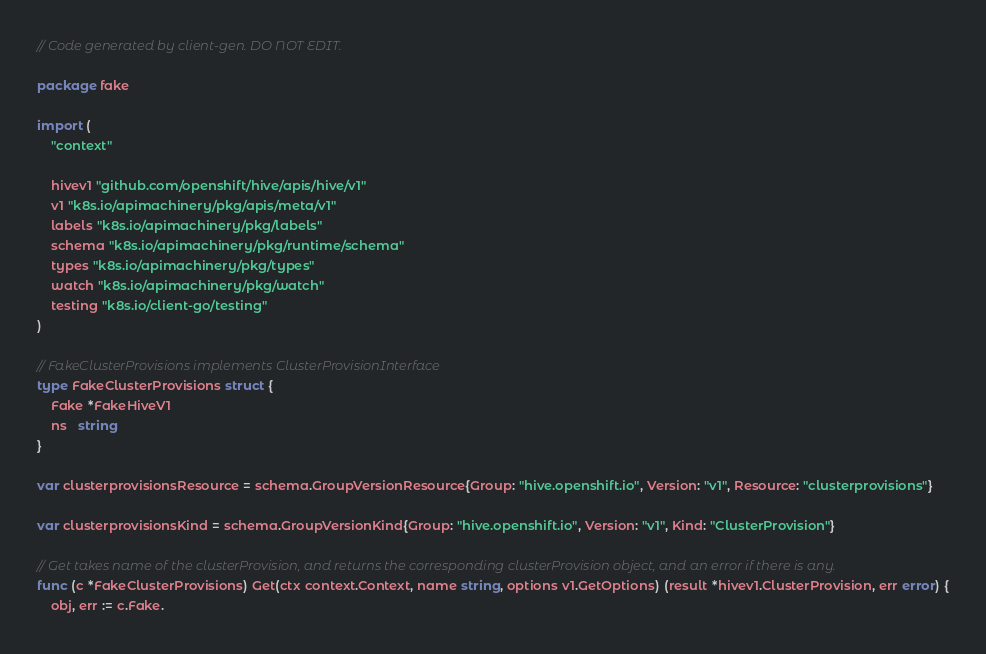<code> <loc_0><loc_0><loc_500><loc_500><_Go_>// Code generated by client-gen. DO NOT EDIT.

package fake

import (
	"context"

	hivev1 "github.com/openshift/hive/apis/hive/v1"
	v1 "k8s.io/apimachinery/pkg/apis/meta/v1"
	labels "k8s.io/apimachinery/pkg/labels"
	schema "k8s.io/apimachinery/pkg/runtime/schema"
	types "k8s.io/apimachinery/pkg/types"
	watch "k8s.io/apimachinery/pkg/watch"
	testing "k8s.io/client-go/testing"
)

// FakeClusterProvisions implements ClusterProvisionInterface
type FakeClusterProvisions struct {
	Fake *FakeHiveV1
	ns   string
}

var clusterprovisionsResource = schema.GroupVersionResource{Group: "hive.openshift.io", Version: "v1", Resource: "clusterprovisions"}

var clusterprovisionsKind = schema.GroupVersionKind{Group: "hive.openshift.io", Version: "v1", Kind: "ClusterProvision"}

// Get takes name of the clusterProvision, and returns the corresponding clusterProvision object, and an error if there is any.
func (c *FakeClusterProvisions) Get(ctx context.Context, name string, options v1.GetOptions) (result *hivev1.ClusterProvision, err error) {
	obj, err := c.Fake.</code> 